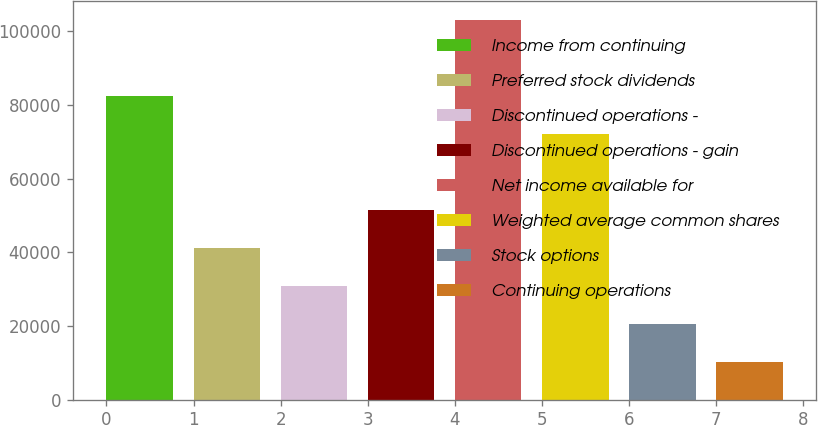Convert chart to OTSL. <chart><loc_0><loc_0><loc_500><loc_500><bar_chart><fcel>Income from continuing<fcel>Preferred stock dividends<fcel>Discontinued operations -<fcel>Discontinued operations - gain<fcel>Net income available for<fcel>Weighted average common shares<fcel>Stock options<fcel>Continuing operations<nl><fcel>82509.7<fcel>41255.2<fcel>30941.5<fcel>51568.8<fcel>103137<fcel>72196.1<fcel>20627.9<fcel>10314.2<nl></chart> 